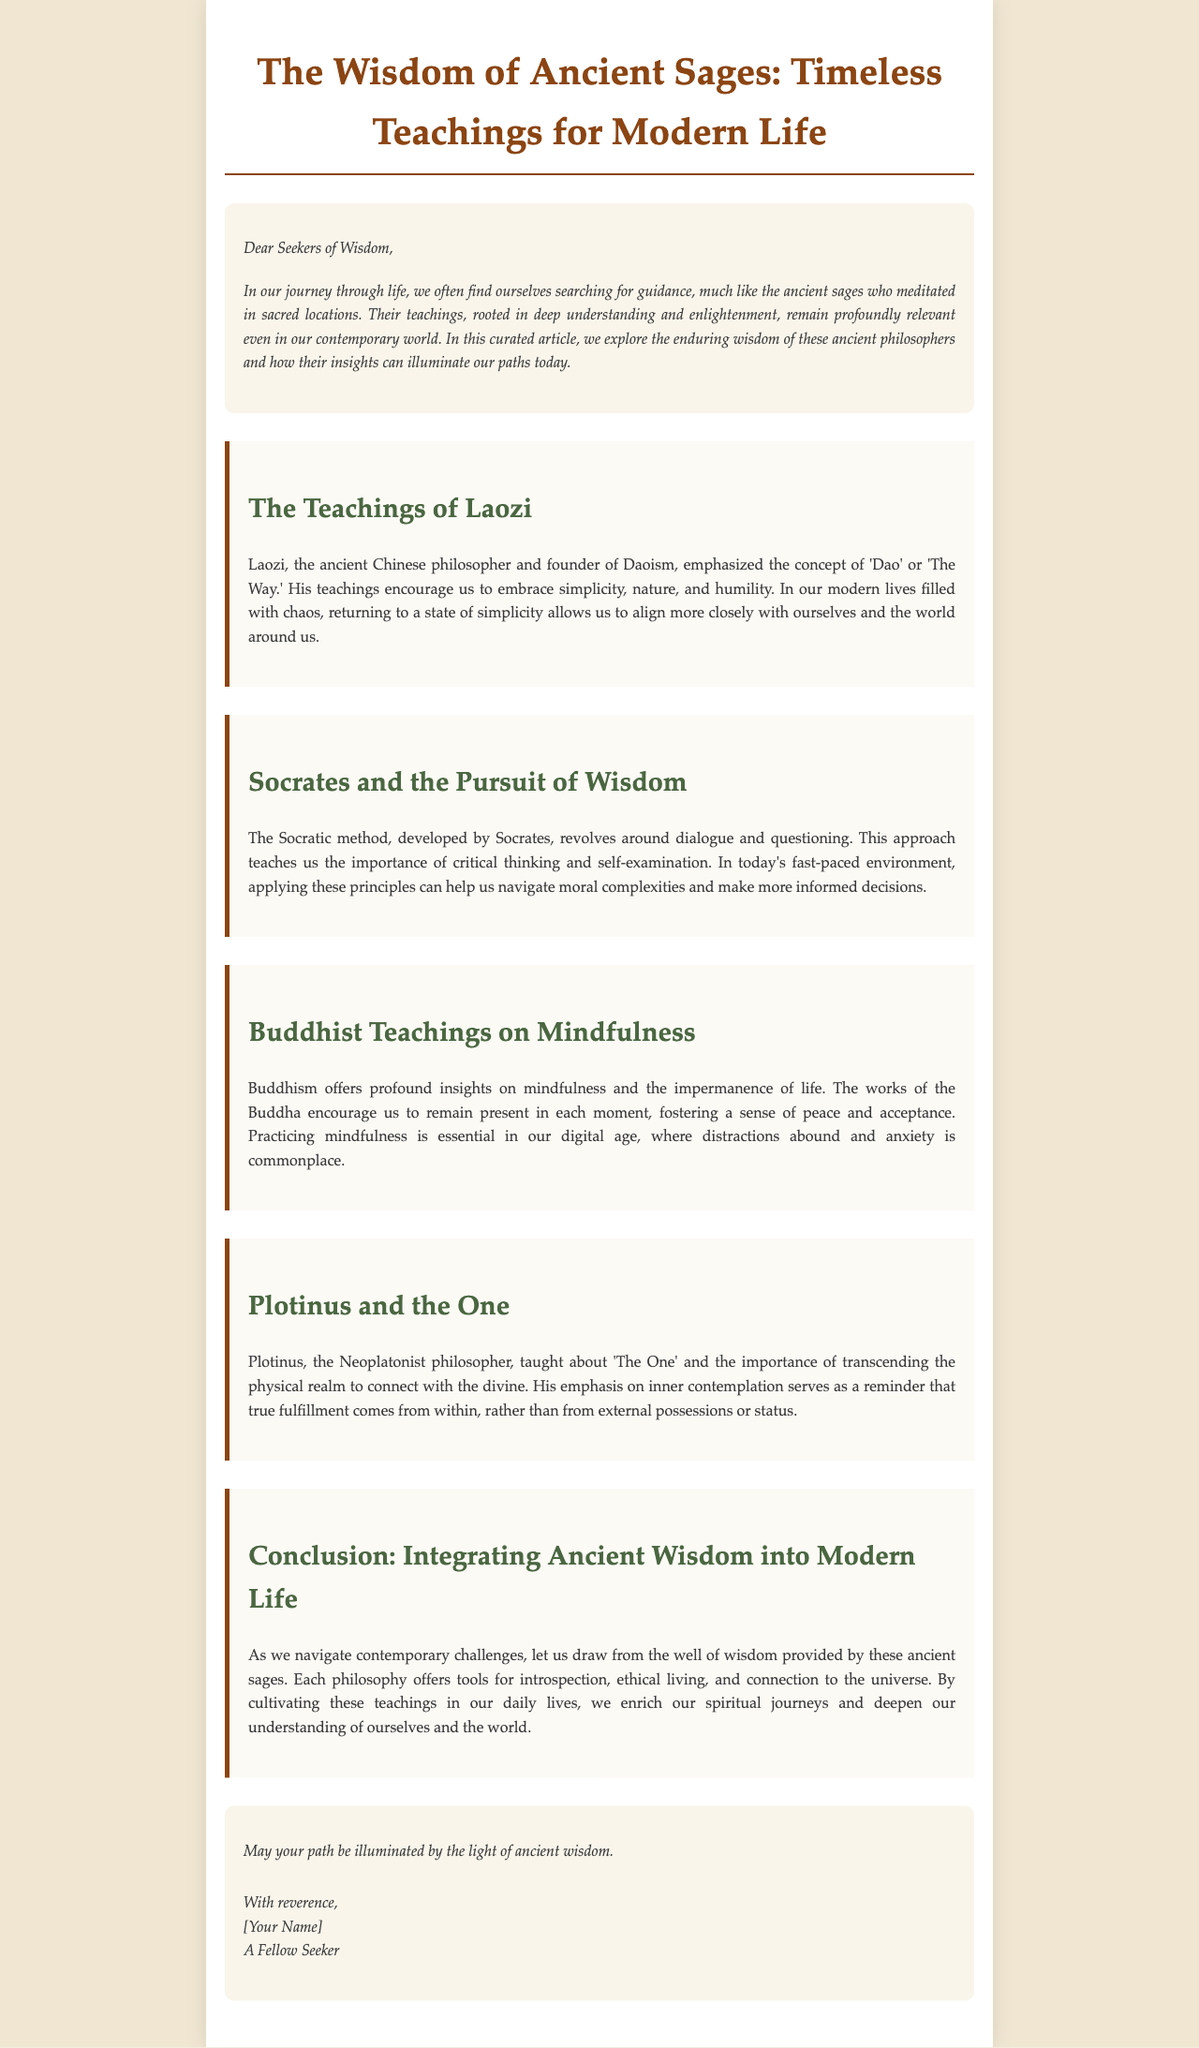What is the title of the article? The title of the article is prominently displayed in the document as "The Wisdom of Ancient Sages: Timeless Teachings for Modern Life."
Answer: The Wisdom of Ancient Sages: Timeless Teachings for Modern Life Who is the founder of Daoism mentioned in the article? The article references Laozi as the ancient Chinese philosopher and founder of Daoism.
Answer: Laozi What philosophical method is associated with Socrates? The document states that the Socratic method is associated with Socrates, focusing on dialogue and questioning.
Answer: Socratic method What is emphasized in Buddhist teachings according to the article? The article emphasizes mindfulness and the impermanence of life as key teachings of Buddhism.
Answer: Mindfulness What does Plotinus teach about? The document indicates that Plotinus teaches about "The One" and transcending the physical realm.
Answer: The One How does the article suggest integrating ancient wisdom into modern life? The article suggests drawing from the wisdom of ancient sages to enrich spiritual journeys and deepen understanding.
Answer: Enrich spiritual journeys What element of living does Laozi encourage? The document states that Laozi encourages embracing simplicity, nature, and humility in life.
Answer: Simplicity What is the tone of the closing remarks in the article? The closing remarks have a reflective and reverent tone, urging readers to let ancient wisdom illuminate their paths.
Answer: Reflective and reverent How many sections does the article contain? The article contains four sections, each dedicated to a different philosophical teaching.
Answer: Four 